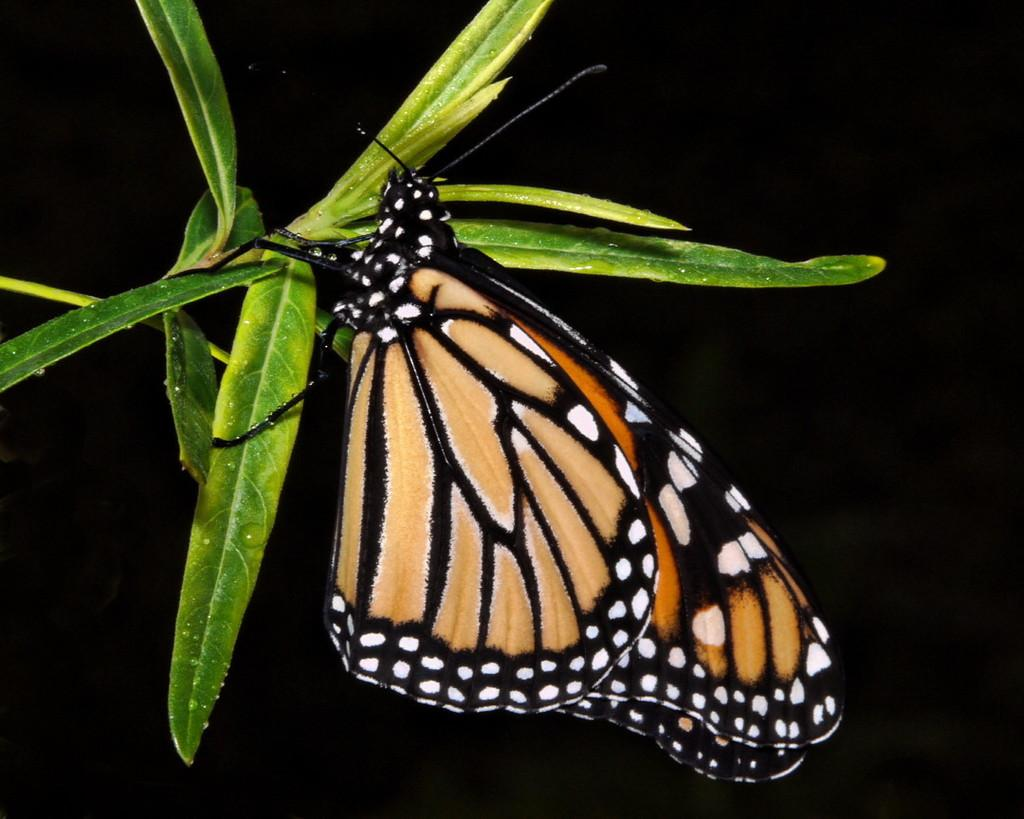What is the main subject in the foreground of the image? There is a butterfly in the foreground of the image. What is the butterfly resting on? The butterfly is on a plant. How would you describe the background of the image? The background of the image is dark. What is the range of the butterfly's mind in the image? There is no indication of the butterfly's mental capabilities or range in the image, as it is a photograph of a butterfly on a plant. 